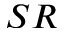Convert formula to latex. <formula><loc_0><loc_0><loc_500><loc_500>_ { S R }</formula> 